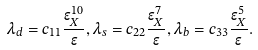<formula> <loc_0><loc_0><loc_500><loc_500>\lambda _ { d } = c _ { 1 1 } \frac { \epsilon _ { X } ^ { 1 0 } } { \epsilon } , \lambda _ { s } = c _ { 2 2 } \frac { \epsilon _ { X } ^ { 7 } } { \epsilon } , \lambda _ { b } = c _ { 3 3 } \frac { \epsilon _ { X } ^ { 5 } } { \epsilon } .</formula> 